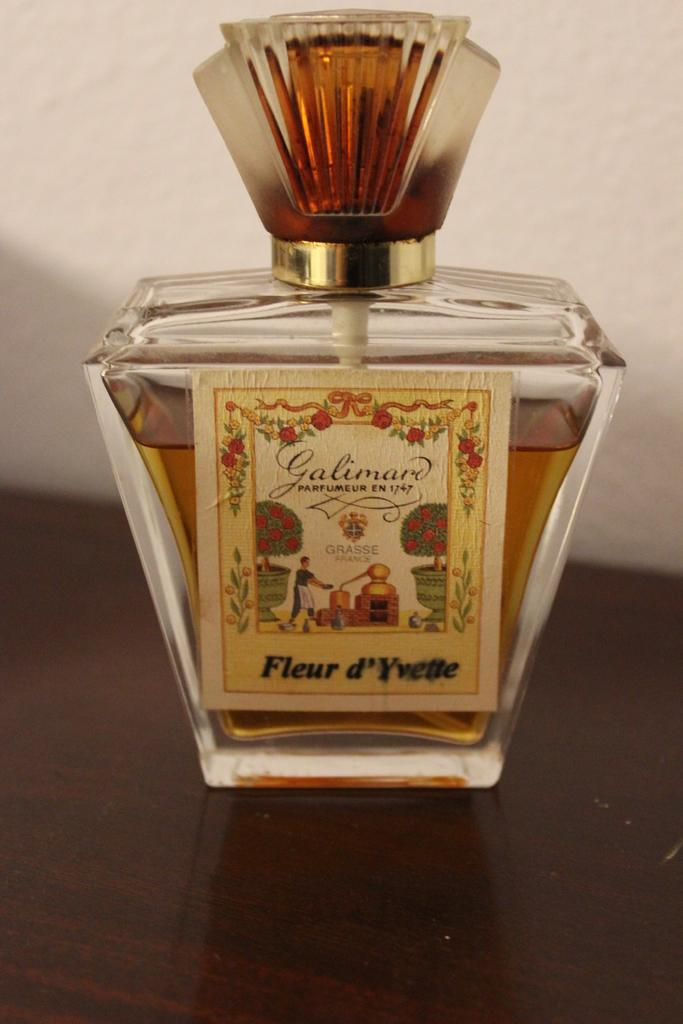<image>
Describe the image concisely. A bottle of Galimard parfumeur en 1747 sitting on a table. 